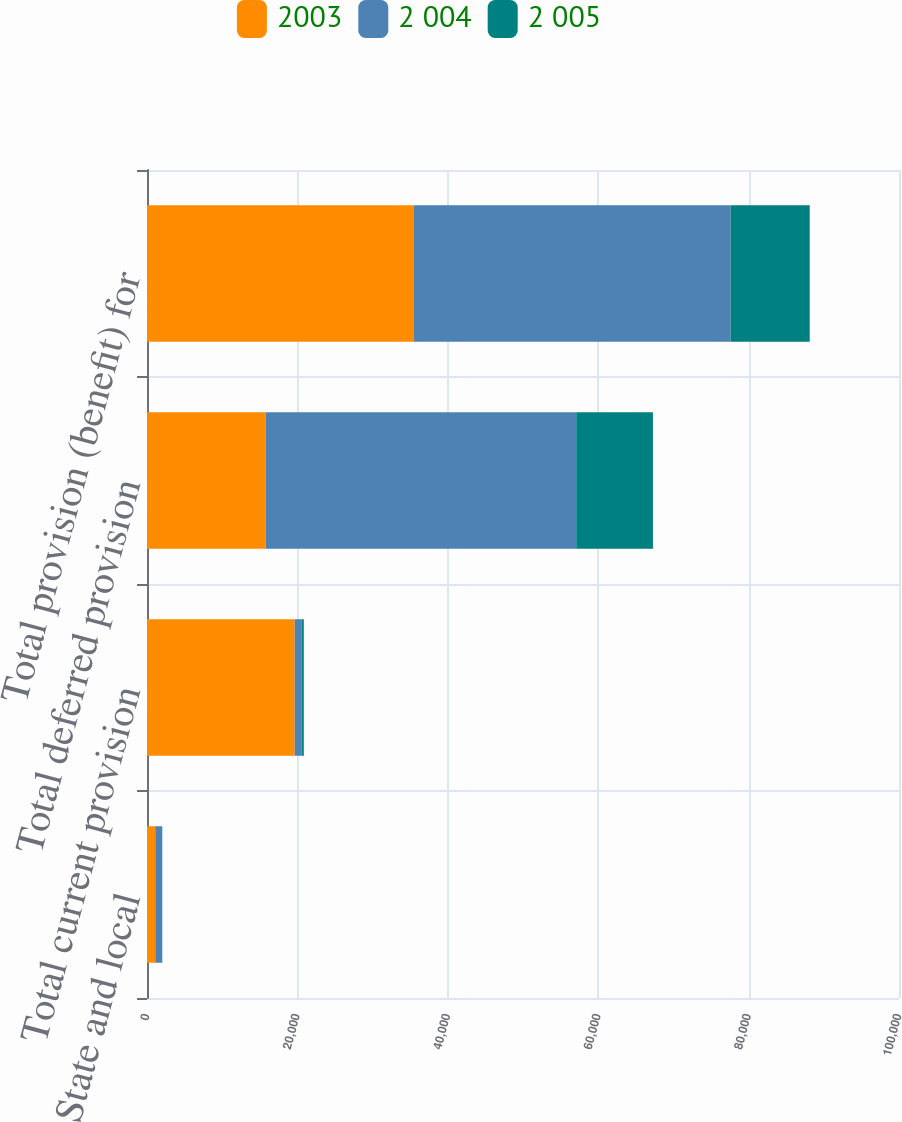Convert chart. <chart><loc_0><loc_0><loc_500><loc_500><stacked_bar_chart><ecel><fcel>State and local<fcel>Total current provision<fcel>Total deferred provision<fcel>Total provision (benefit) for<nl><fcel>2003<fcel>1099<fcel>19642<fcel>15788<fcel>35430<nl><fcel>2 004<fcel>895<fcel>895<fcel>41290<fcel>42185<nl><fcel>2 005<fcel>32<fcel>314<fcel>10202<fcel>10516<nl></chart> 